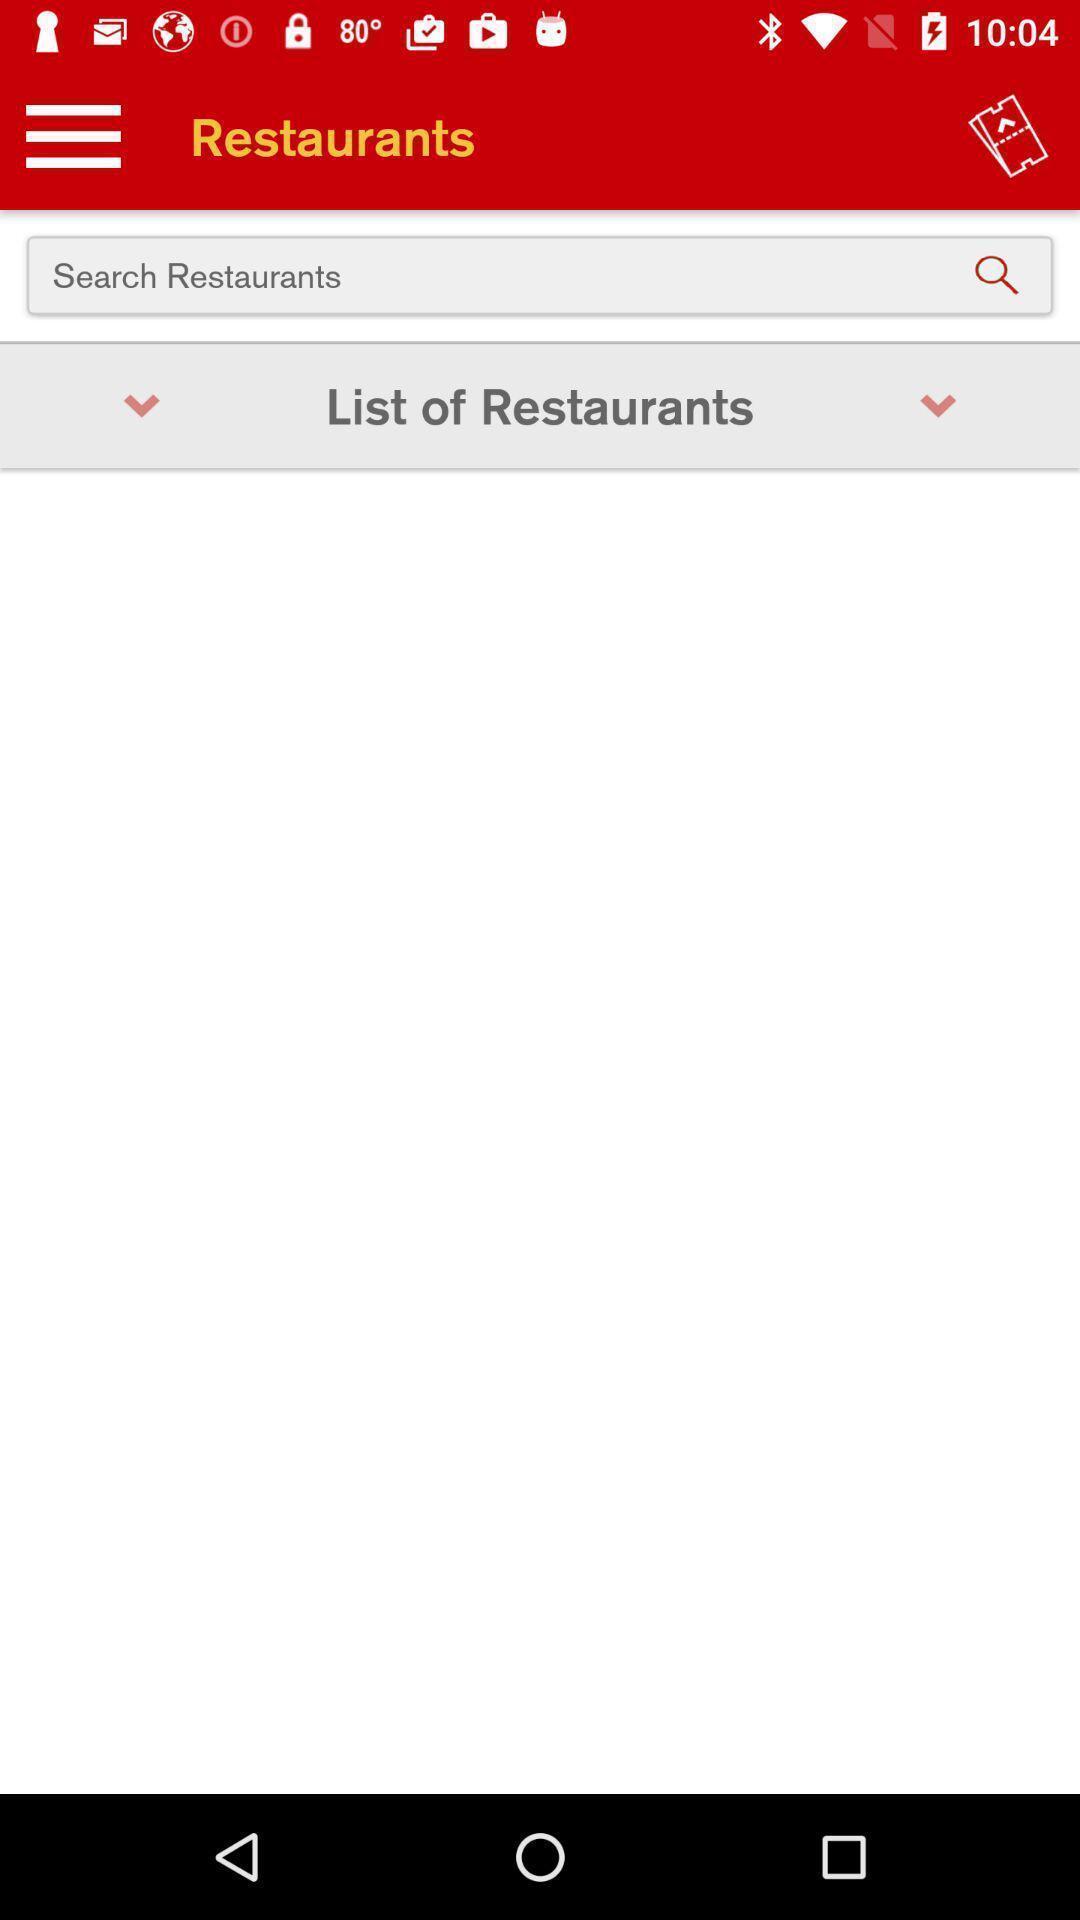Give me a summary of this screen capture. Screen showing the search bar in food app. 